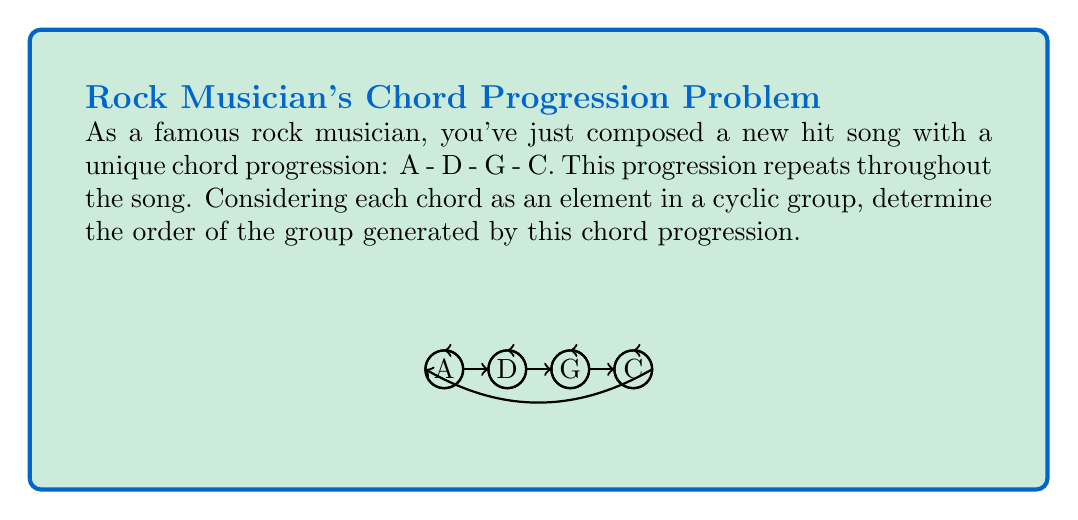Can you solve this math problem? Let's approach this step-by-step:

1) In group theory, the order of a cyclic group is the number of unique elements generated by repeatedly applying the group operation to the generator.

2) In this case, our generator is the chord progression A - D - G - C, and the group operation is concatenation of progressions.

3) Let's list out the elements generated by repeatedly applying this progression:
   
   Element 1: A - D - G - C
   Element 2: A - D - G - C - A - D - G - C
   Element 3: A - D - G - C - A - D - G - C - A - D - G - C
   Element 4: A - D - G - C - A - D - G - C - A - D - G - C - A - D - G - C

4) We can see that after applying the progression 4 times, we return to where we started (A).

5) This means that the group "cycles" every 4 applications of the generator.

6) Therefore, the order of the cyclic group is 4.

In mathematical notation, if we denote the generator as $g = (A-D-G-C)$, then the group is:

$$ \langle g \rangle = \{g^1, g^2, g^3, g^4 = e\} $$

Where $e$ is the identity element (in this case, returning to the starting point A).
Answer: 4 